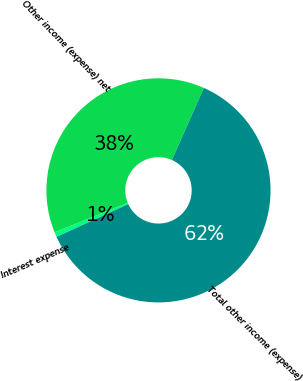Convert chart. <chart><loc_0><loc_0><loc_500><loc_500><pie_chart><fcel>Interest expense<fcel>Other income (expense) net<fcel>Total other income (expense)<nl><fcel>0.71%<fcel>37.74%<fcel>61.55%<nl></chart> 